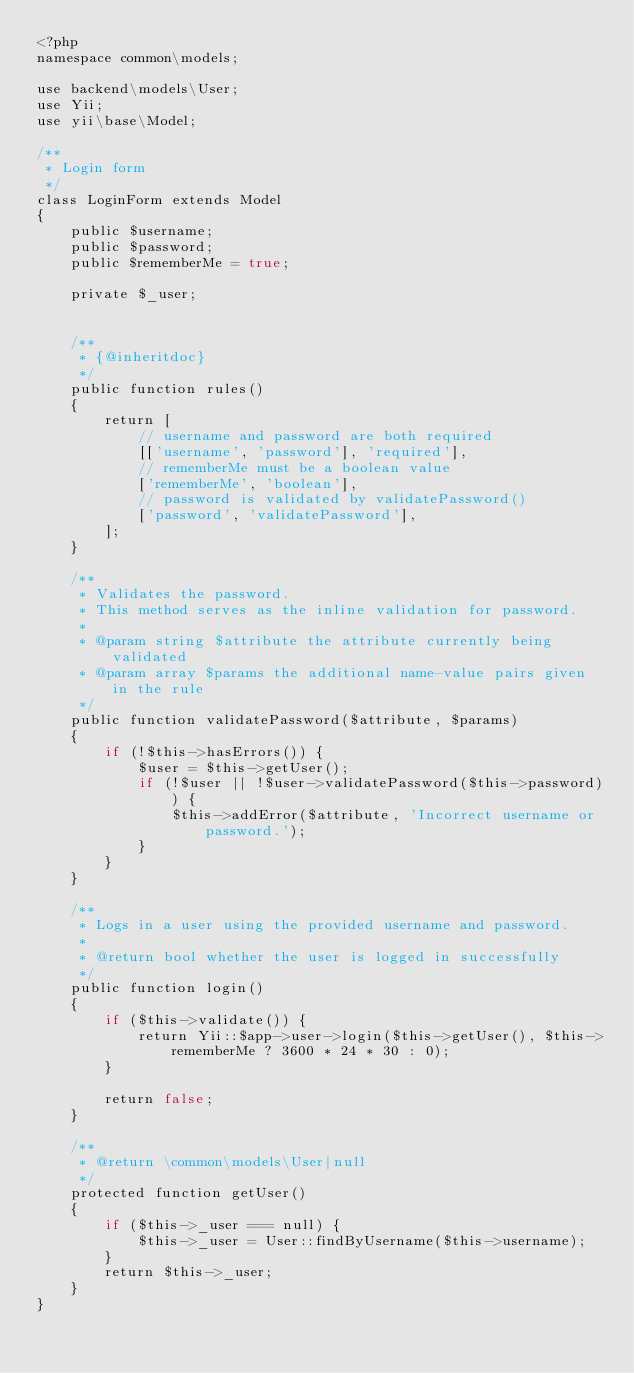<code> <loc_0><loc_0><loc_500><loc_500><_PHP_><?php
namespace common\models;

use backend\models\User;
use Yii;
use yii\base\Model;

/**
 * Login form
 */
class LoginForm extends Model
{
    public $username;
    public $password;
    public $rememberMe = true;

    private $_user;


    /**
     * {@inheritdoc}
     */
    public function rules()
    {
        return [
            // username and password are both required
            [['username', 'password'], 'required'],
            // rememberMe must be a boolean value
            ['rememberMe', 'boolean'],
            // password is validated by validatePassword()
            ['password', 'validatePassword'],
        ];
    }

    /**
     * Validates the password.
     * This method serves as the inline validation for password.
     *
     * @param string $attribute the attribute currently being validated
     * @param array $params the additional name-value pairs given in the rule
     */
    public function validatePassword($attribute, $params)
    {
        if (!$this->hasErrors()) {
            $user = $this->getUser();
            if (!$user || !$user->validatePassword($this->password)) {
                $this->addError($attribute, 'Incorrect username or password.');
            }
        }
    }

    /**
     * Logs in a user using the provided username and password.
     *
     * @return bool whether the user is logged in successfully
     */
    public function login()
    {
        if ($this->validate()) {
            return Yii::$app->user->login($this->getUser(), $this->rememberMe ? 3600 * 24 * 30 : 0);
        }

        return false;
    }

    /**
     * @return \common\models\User|null
     */
    protected function getUser()
    {
        if ($this->_user === null) {
            $this->_user = User::findByUsername($this->username);
        }
        return $this->_user;
    }
}
</code> 